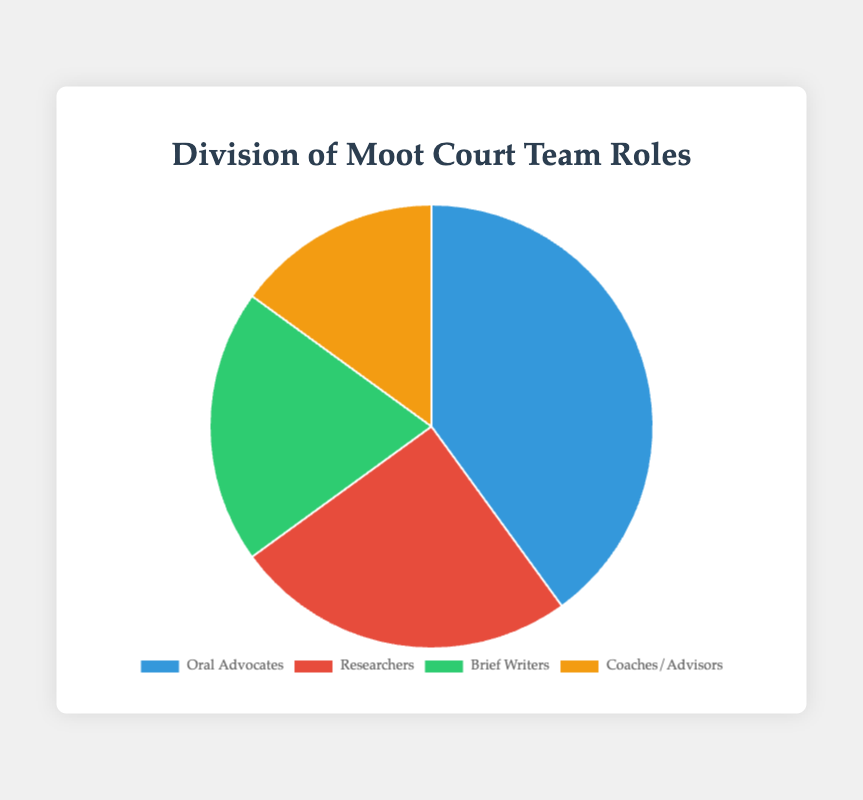What percentage of the moot court team roles does the combined percentage of Brief Writers and Coaches/Advisors represent? The percentage for Brief Writers is 20% and for Coaches/Advisors is 15%. Adding these two percentages together gives us 20% + 15% = 35%.
Answer: 35% Which role has the highest representation in the pie chart? By looking at the pie chart, we see that Oral Advocates have the largest slice, representing 40% of the total.
Answer: Oral Advocates How many more percent are Oral Advocates than Researchers? Oral Advocates represent 40% and Researchers represent 25%. To find the difference, we subtract 25% from 40%, which gives us 40% - 25% = 15%.
Answer: 15% What is the percentage difference between the role with the smallest representation and the role with the largest representation? The smallest representation is for Coaches/Advisors at 15% and the largest is for Oral Advocates at 40%. The difference is 40% - 15% = 25%.
Answer: 25% If you sum the percentages of Oral Advocates, Researchers, and Brief Writers, what percentage of the team do they represent? Adding the percentages for Oral Advocates (40%), Researchers (25%), and Brief Writers (20%) gives us 40% + 25% + 20% = 85%.
Answer: 85% How are the roles visually differentiated in the pie chart? The roles are visually differentiated by using different colors for each slice of the pie.
Answer: Different colors Which two roles together make up exactly half of the moot court teams’ roles? Adding the percentages for Researchers (25%) and Brief Writers (20%) gives us 25% + 20% = 45%. But, adding the percentages for Oral Advocates (40%) and Coaches/Advisors (15%) gives us 40% + 15% = 55%. Thus, no two roles combine to exactly 50%.
Answer: None Based on visual inspection, which role appears to have the second-largest representation in the pie chart? By looking at the pie chart, the second-largest slice corresponds to Researchers, taking up 25% of the chart.
Answer: Researchers Of the four roles, how many have a representation of at least 20%? Oral Advocates have 40% and Brief Writers have 20%. Researchers have 25%. Coaches/Advisors have below 20%. So the number is three roles.
Answer: 3 